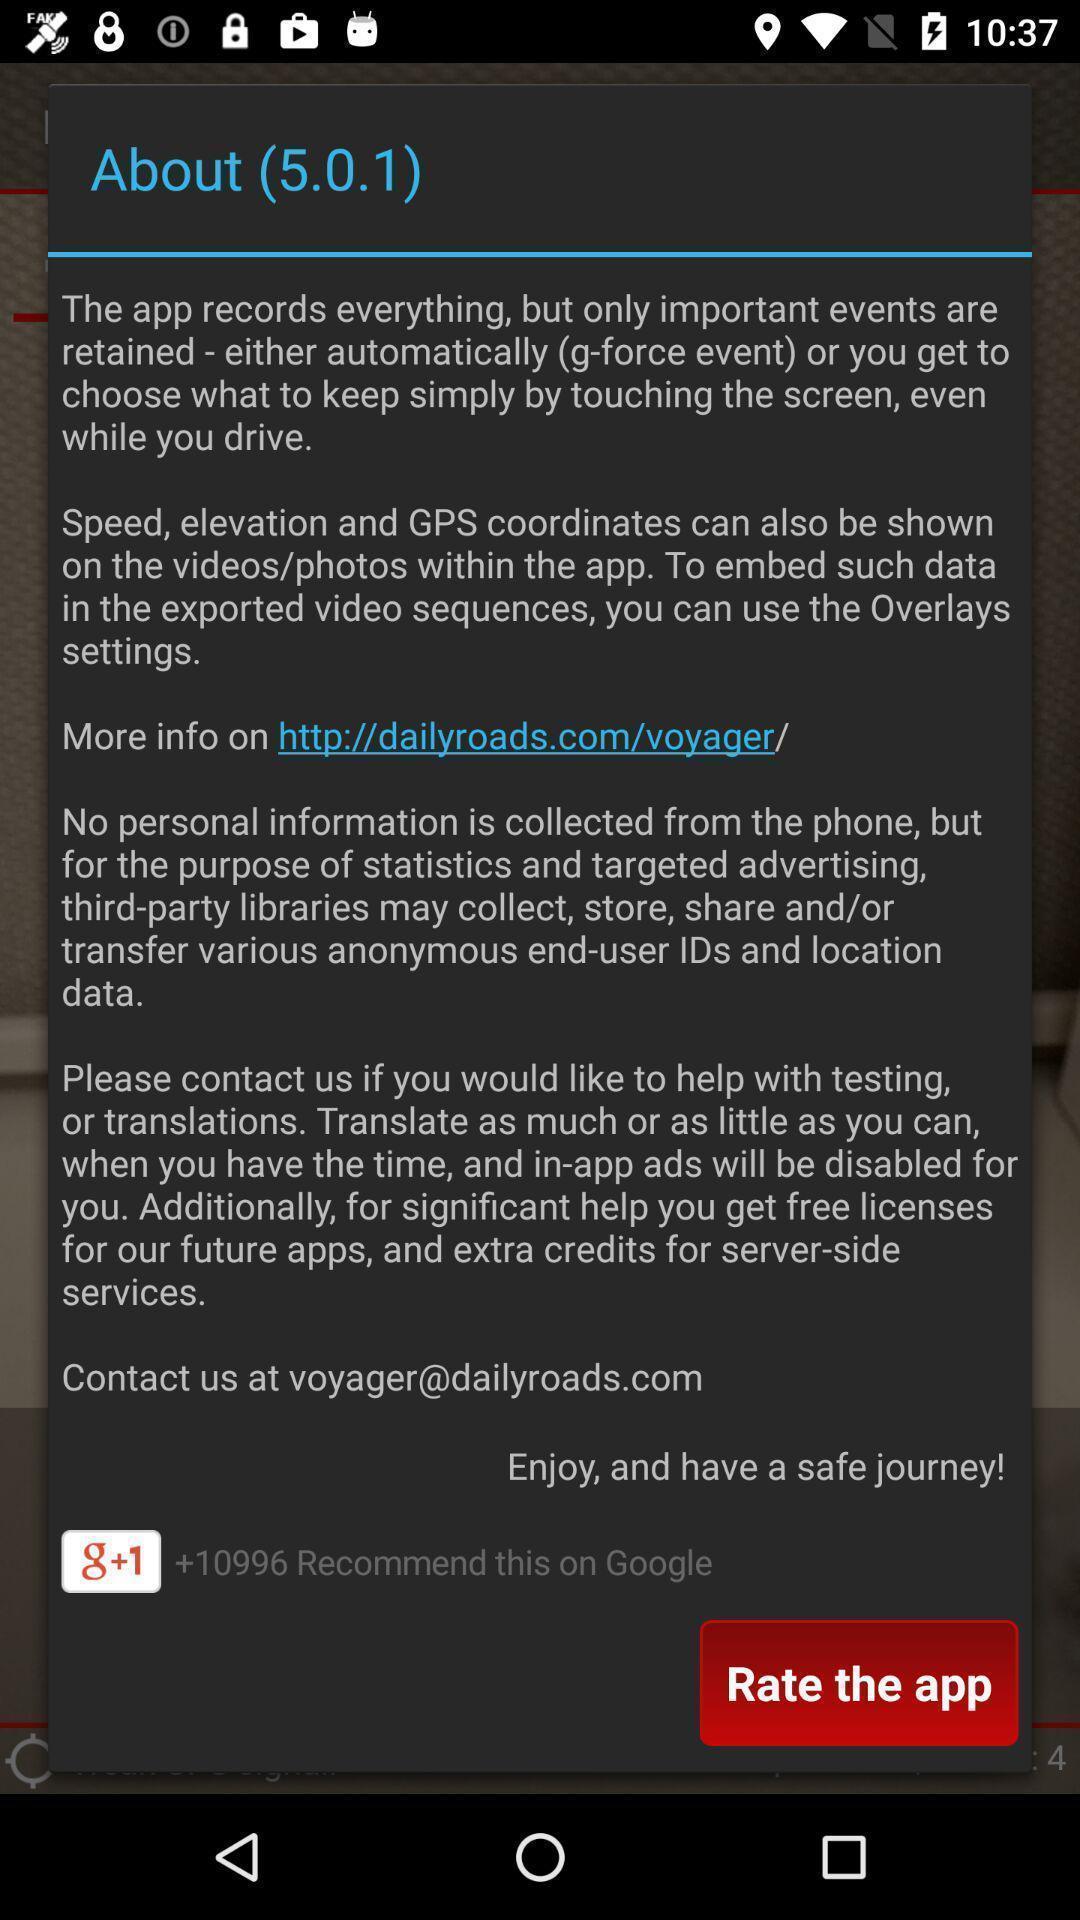Provide a detailed account of this screenshot. Pop-up shows about page. 